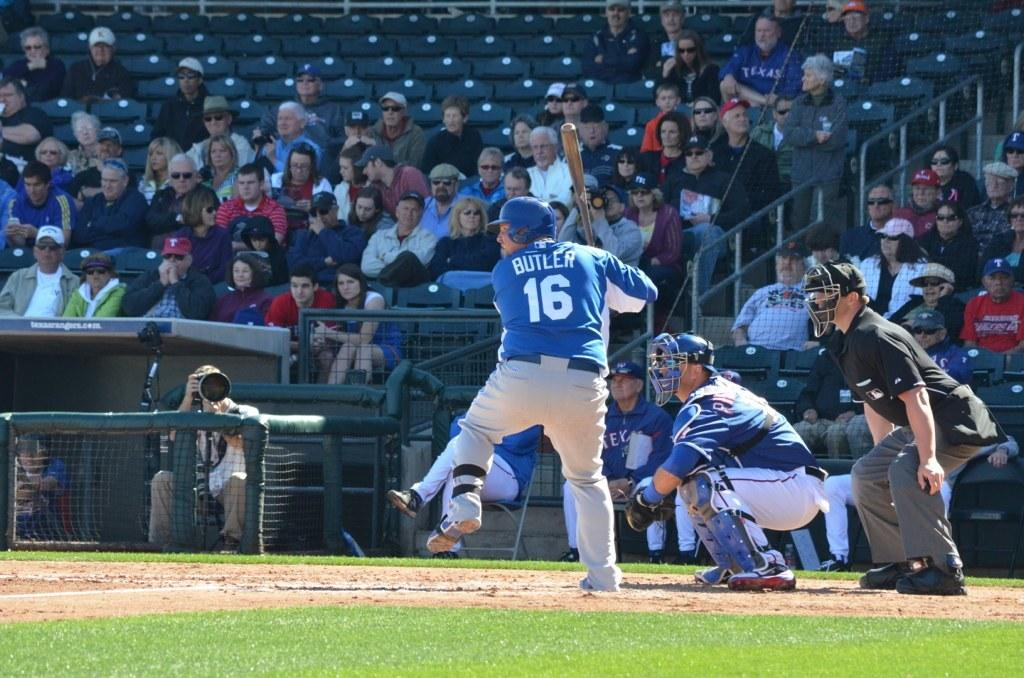<image>
Describe the image concisely. A batter named Butler is about to take a swing. 